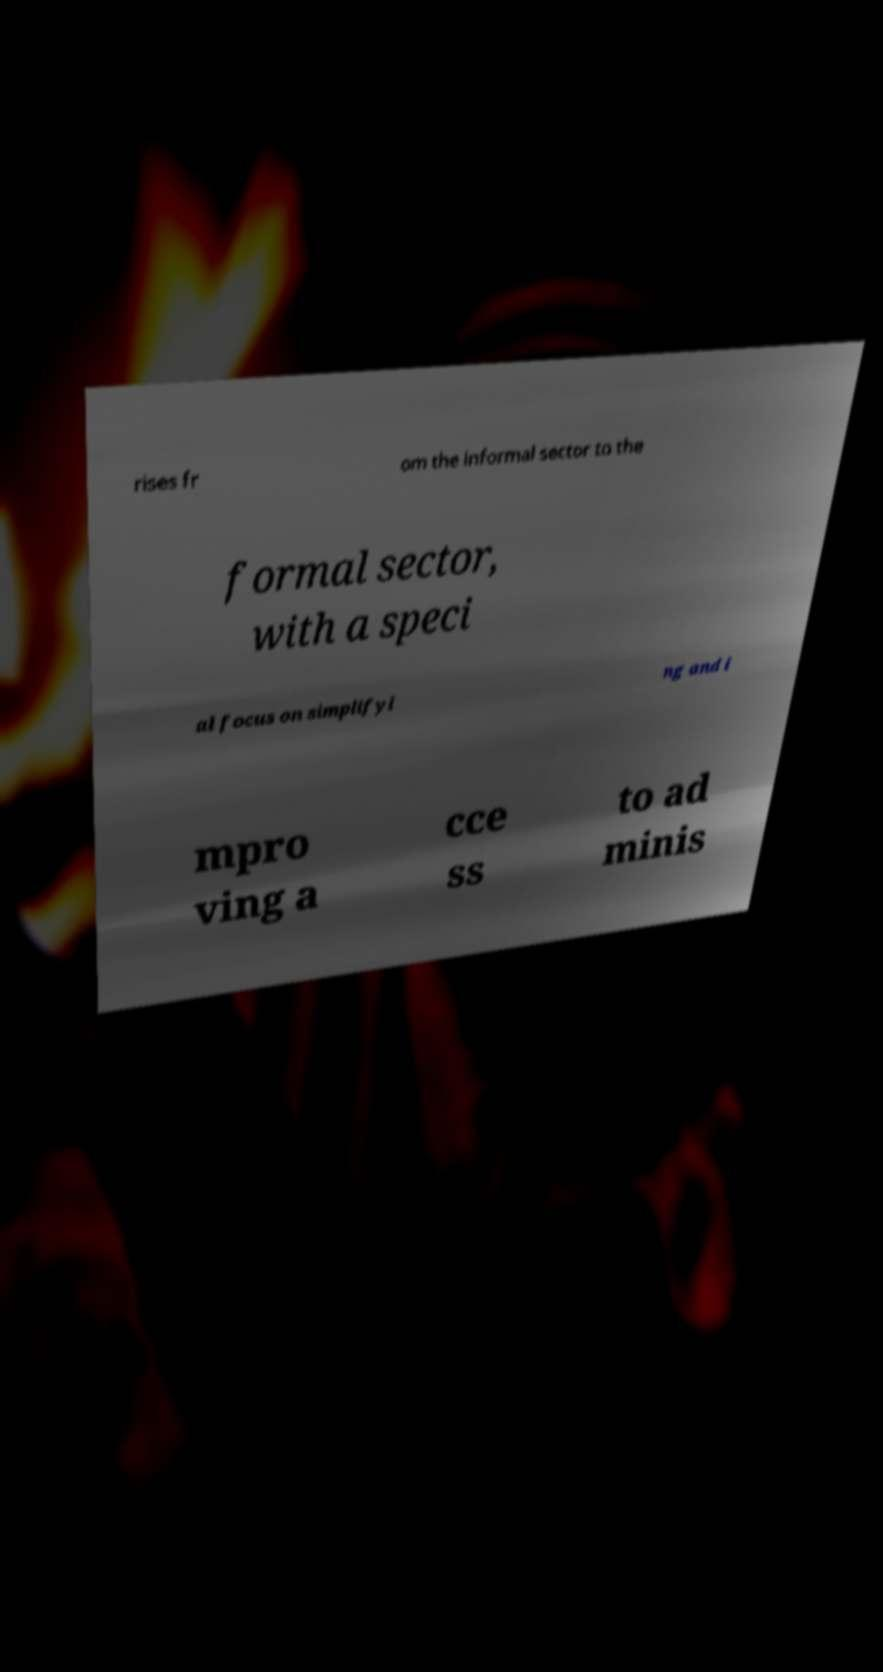Can you accurately transcribe the text from the provided image for me? rises fr om the informal sector to the formal sector, with a speci al focus on simplifyi ng and i mpro ving a cce ss to ad minis 